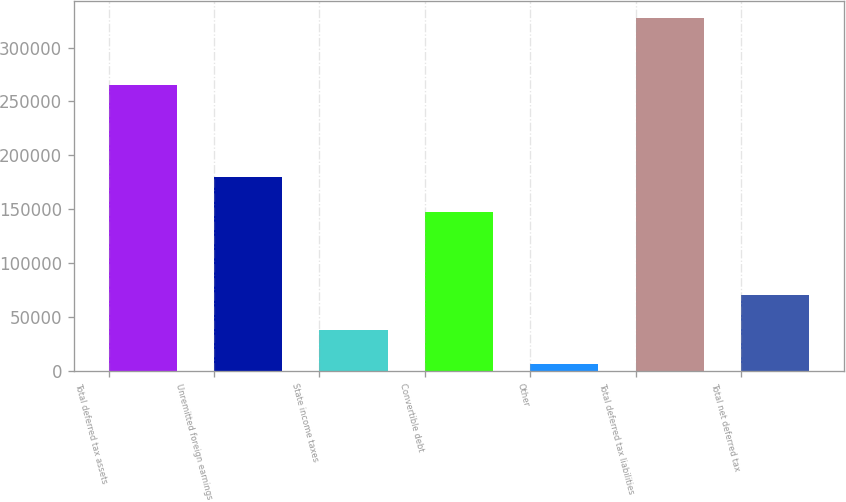<chart> <loc_0><loc_0><loc_500><loc_500><bar_chart><fcel>Total deferred tax assets<fcel>Unremitted foreign earnings<fcel>State income taxes<fcel>Convertible debt<fcel>Other<fcel>Total deferred tax liabilities<fcel>Total net deferred tax<nl><fcel>265101<fcel>179962<fcel>38253.9<fcel>147856<fcel>6148<fcel>327207<fcel>70359.8<nl></chart> 